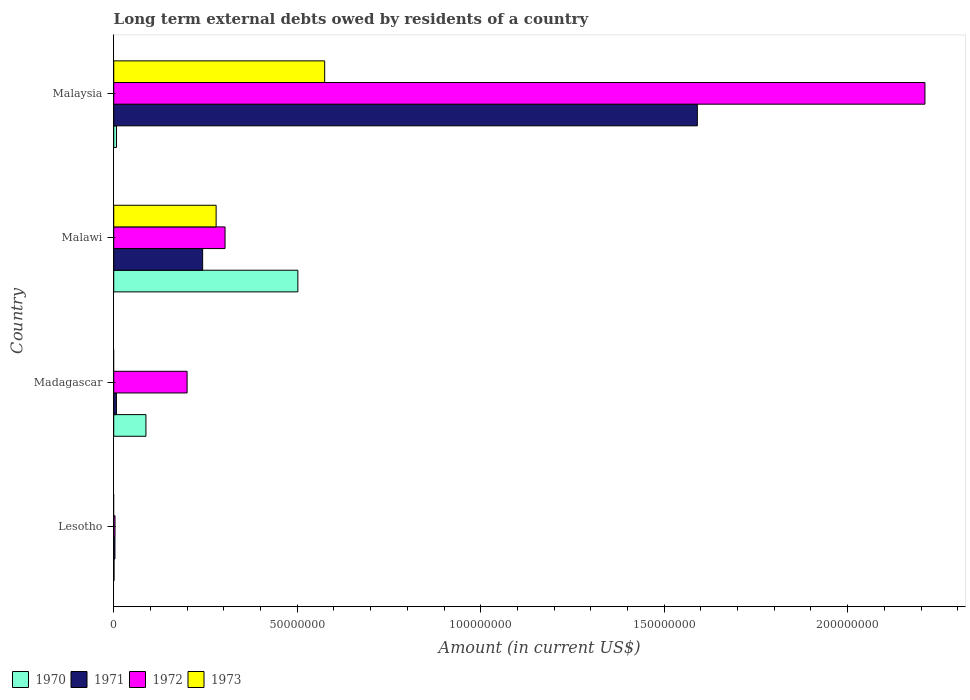How many groups of bars are there?
Offer a terse response. 4. Are the number of bars on each tick of the Y-axis equal?
Provide a succinct answer. No. What is the label of the 2nd group of bars from the top?
Your response must be concise. Malawi. What is the amount of long-term external debts owed by residents in 1970 in Lesotho?
Make the answer very short. 7.60e+04. Across all countries, what is the maximum amount of long-term external debts owed by residents in 1973?
Your response must be concise. 5.75e+07. Across all countries, what is the minimum amount of long-term external debts owed by residents in 1970?
Give a very brief answer. 7.60e+04. In which country was the amount of long-term external debts owed by residents in 1972 maximum?
Your answer should be compact. Malaysia. What is the total amount of long-term external debts owed by residents in 1972 in the graph?
Provide a succinct answer. 2.72e+08. What is the difference between the amount of long-term external debts owed by residents in 1971 in Madagascar and that in Malaysia?
Provide a succinct answer. -1.58e+08. What is the difference between the amount of long-term external debts owed by residents in 1971 in Malaysia and the amount of long-term external debts owed by residents in 1970 in Lesotho?
Make the answer very short. 1.59e+08. What is the average amount of long-term external debts owed by residents in 1972 per country?
Make the answer very short. 6.79e+07. What is the difference between the amount of long-term external debts owed by residents in 1970 and amount of long-term external debts owed by residents in 1971 in Lesotho?
Provide a succinct answer. -2.50e+05. In how many countries, is the amount of long-term external debts owed by residents in 1972 greater than 60000000 US$?
Offer a very short reply. 1. What is the ratio of the amount of long-term external debts owed by residents in 1973 in Malawi to that in Malaysia?
Your answer should be compact. 0.49. What is the difference between the highest and the second highest amount of long-term external debts owed by residents in 1970?
Your answer should be very brief. 4.14e+07. What is the difference between the highest and the lowest amount of long-term external debts owed by residents in 1970?
Offer a terse response. 5.01e+07. Is it the case that in every country, the sum of the amount of long-term external debts owed by residents in 1971 and amount of long-term external debts owed by residents in 1972 is greater than the sum of amount of long-term external debts owed by residents in 1970 and amount of long-term external debts owed by residents in 1973?
Offer a very short reply. No. How many bars are there?
Ensure brevity in your answer.  14. Are all the bars in the graph horizontal?
Offer a very short reply. Yes. What is the difference between two consecutive major ticks on the X-axis?
Keep it short and to the point. 5.00e+07. Are the values on the major ticks of X-axis written in scientific E-notation?
Your answer should be compact. No. Does the graph contain grids?
Provide a short and direct response. No. What is the title of the graph?
Give a very brief answer. Long term external debts owed by residents of a country. What is the Amount (in current US$) of 1970 in Lesotho?
Provide a succinct answer. 7.60e+04. What is the Amount (in current US$) of 1971 in Lesotho?
Your answer should be compact. 3.26e+05. What is the Amount (in current US$) of 1972 in Lesotho?
Keep it short and to the point. 3.48e+05. What is the Amount (in current US$) of 1973 in Lesotho?
Offer a terse response. 0. What is the Amount (in current US$) of 1970 in Madagascar?
Give a very brief answer. 8.78e+06. What is the Amount (in current US$) of 1971 in Madagascar?
Ensure brevity in your answer.  7.30e+05. What is the Amount (in current US$) in 1972 in Madagascar?
Provide a succinct answer. 2.00e+07. What is the Amount (in current US$) of 1970 in Malawi?
Ensure brevity in your answer.  5.02e+07. What is the Amount (in current US$) of 1971 in Malawi?
Your answer should be very brief. 2.42e+07. What is the Amount (in current US$) in 1972 in Malawi?
Your answer should be compact. 3.03e+07. What is the Amount (in current US$) of 1973 in Malawi?
Your answer should be compact. 2.79e+07. What is the Amount (in current US$) of 1970 in Malaysia?
Keep it short and to the point. 7.56e+05. What is the Amount (in current US$) in 1971 in Malaysia?
Give a very brief answer. 1.59e+08. What is the Amount (in current US$) in 1972 in Malaysia?
Offer a very short reply. 2.21e+08. What is the Amount (in current US$) of 1973 in Malaysia?
Give a very brief answer. 5.75e+07. Across all countries, what is the maximum Amount (in current US$) in 1970?
Offer a terse response. 5.02e+07. Across all countries, what is the maximum Amount (in current US$) of 1971?
Provide a succinct answer. 1.59e+08. Across all countries, what is the maximum Amount (in current US$) of 1972?
Offer a very short reply. 2.21e+08. Across all countries, what is the maximum Amount (in current US$) in 1973?
Provide a succinct answer. 5.75e+07. Across all countries, what is the minimum Amount (in current US$) in 1970?
Ensure brevity in your answer.  7.60e+04. Across all countries, what is the minimum Amount (in current US$) of 1971?
Your answer should be compact. 3.26e+05. Across all countries, what is the minimum Amount (in current US$) of 1972?
Offer a terse response. 3.48e+05. Across all countries, what is the minimum Amount (in current US$) in 1973?
Keep it short and to the point. 0. What is the total Amount (in current US$) in 1970 in the graph?
Ensure brevity in your answer.  5.98e+07. What is the total Amount (in current US$) of 1971 in the graph?
Ensure brevity in your answer.  1.84e+08. What is the total Amount (in current US$) in 1972 in the graph?
Provide a short and direct response. 2.72e+08. What is the total Amount (in current US$) in 1973 in the graph?
Offer a terse response. 8.54e+07. What is the difference between the Amount (in current US$) in 1970 in Lesotho and that in Madagascar?
Your response must be concise. -8.70e+06. What is the difference between the Amount (in current US$) of 1971 in Lesotho and that in Madagascar?
Offer a terse response. -4.04e+05. What is the difference between the Amount (in current US$) in 1972 in Lesotho and that in Madagascar?
Keep it short and to the point. -1.96e+07. What is the difference between the Amount (in current US$) of 1970 in Lesotho and that in Malawi?
Your answer should be very brief. -5.01e+07. What is the difference between the Amount (in current US$) in 1971 in Lesotho and that in Malawi?
Your answer should be very brief. -2.39e+07. What is the difference between the Amount (in current US$) in 1972 in Lesotho and that in Malawi?
Offer a terse response. -3.00e+07. What is the difference between the Amount (in current US$) in 1970 in Lesotho and that in Malaysia?
Your response must be concise. -6.80e+05. What is the difference between the Amount (in current US$) in 1971 in Lesotho and that in Malaysia?
Keep it short and to the point. -1.59e+08. What is the difference between the Amount (in current US$) in 1972 in Lesotho and that in Malaysia?
Offer a very short reply. -2.21e+08. What is the difference between the Amount (in current US$) of 1970 in Madagascar and that in Malawi?
Provide a succinct answer. -4.14e+07. What is the difference between the Amount (in current US$) in 1971 in Madagascar and that in Malawi?
Keep it short and to the point. -2.35e+07. What is the difference between the Amount (in current US$) of 1972 in Madagascar and that in Malawi?
Your response must be concise. -1.03e+07. What is the difference between the Amount (in current US$) of 1970 in Madagascar and that in Malaysia?
Ensure brevity in your answer.  8.02e+06. What is the difference between the Amount (in current US$) of 1971 in Madagascar and that in Malaysia?
Provide a short and direct response. -1.58e+08. What is the difference between the Amount (in current US$) in 1972 in Madagascar and that in Malaysia?
Give a very brief answer. -2.01e+08. What is the difference between the Amount (in current US$) in 1970 in Malawi and that in Malaysia?
Make the answer very short. 4.94e+07. What is the difference between the Amount (in current US$) in 1971 in Malawi and that in Malaysia?
Make the answer very short. -1.35e+08. What is the difference between the Amount (in current US$) of 1972 in Malawi and that in Malaysia?
Provide a succinct answer. -1.91e+08. What is the difference between the Amount (in current US$) of 1973 in Malawi and that in Malaysia?
Offer a very short reply. -2.96e+07. What is the difference between the Amount (in current US$) in 1970 in Lesotho and the Amount (in current US$) in 1971 in Madagascar?
Provide a succinct answer. -6.54e+05. What is the difference between the Amount (in current US$) in 1970 in Lesotho and the Amount (in current US$) in 1972 in Madagascar?
Your answer should be compact. -1.99e+07. What is the difference between the Amount (in current US$) in 1971 in Lesotho and the Amount (in current US$) in 1972 in Madagascar?
Offer a terse response. -1.97e+07. What is the difference between the Amount (in current US$) in 1970 in Lesotho and the Amount (in current US$) in 1971 in Malawi?
Your answer should be compact. -2.42e+07. What is the difference between the Amount (in current US$) of 1970 in Lesotho and the Amount (in current US$) of 1972 in Malawi?
Offer a very short reply. -3.03e+07. What is the difference between the Amount (in current US$) in 1970 in Lesotho and the Amount (in current US$) in 1973 in Malawi?
Offer a terse response. -2.78e+07. What is the difference between the Amount (in current US$) of 1971 in Lesotho and the Amount (in current US$) of 1972 in Malawi?
Offer a terse response. -3.00e+07. What is the difference between the Amount (in current US$) in 1971 in Lesotho and the Amount (in current US$) in 1973 in Malawi?
Offer a very short reply. -2.76e+07. What is the difference between the Amount (in current US$) of 1972 in Lesotho and the Amount (in current US$) of 1973 in Malawi?
Provide a short and direct response. -2.76e+07. What is the difference between the Amount (in current US$) in 1970 in Lesotho and the Amount (in current US$) in 1971 in Malaysia?
Make the answer very short. -1.59e+08. What is the difference between the Amount (in current US$) of 1970 in Lesotho and the Amount (in current US$) of 1972 in Malaysia?
Make the answer very short. -2.21e+08. What is the difference between the Amount (in current US$) of 1970 in Lesotho and the Amount (in current US$) of 1973 in Malaysia?
Make the answer very short. -5.74e+07. What is the difference between the Amount (in current US$) of 1971 in Lesotho and the Amount (in current US$) of 1972 in Malaysia?
Provide a succinct answer. -2.21e+08. What is the difference between the Amount (in current US$) in 1971 in Lesotho and the Amount (in current US$) in 1973 in Malaysia?
Offer a terse response. -5.72e+07. What is the difference between the Amount (in current US$) of 1972 in Lesotho and the Amount (in current US$) of 1973 in Malaysia?
Make the answer very short. -5.71e+07. What is the difference between the Amount (in current US$) in 1970 in Madagascar and the Amount (in current US$) in 1971 in Malawi?
Offer a terse response. -1.55e+07. What is the difference between the Amount (in current US$) of 1970 in Madagascar and the Amount (in current US$) of 1972 in Malawi?
Your response must be concise. -2.16e+07. What is the difference between the Amount (in current US$) of 1970 in Madagascar and the Amount (in current US$) of 1973 in Malawi?
Offer a very short reply. -1.91e+07. What is the difference between the Amount (in current US$) of 1971 in Madagascar and the Amount (in current US$) of 1972 in Malawi?
Provide a short and direct response. -2.96e+07. What is the difference between the Amount (in current US$) in 1971 in Madagascar and the Amount (in current US$) in 1973 in Malawi?
Give a very brief answer. -2.72e+07. What is the difference between the Amount (in current US$) in 1972 in Madagascar and the Amount (in current US$) in 1973 in Malawi?
Your answer should be very brief. -7.91e+06. What is the difference between the Amount (in current US$) in 1970 in Madagascar and the Amount (in current US$) in 1971 in Malaysia?
Offer a very short reply. -1.50e+08. What is the difference between the Amount (in current US$) in 1970 in Madagascar and the Amount (in current US$) in 1972 in Malaysia?
Ensure brevity in your answer.  -2.12e+08. What is the difference between the Amount (in current US$) in 1970 in Madagascar and the Amount (in current US$) in 1973 in Malaysia?
Offer a very short reply. -4.87e+07. What is the difference between the Amount (in current US$) in 1971 in Madagascar and the Amount (in current US$) in 1972 in Malaysia?
Give a very brief answer. -2.20e+08. What is the difference between the Amount (in current US$) of 1971 in Madagascar and the Amount (in current US$) of 1973 in Malaysia?
Your response must be concise. -5.68e+07. What is the difference between the Amount (in current US$) in 1972 in Madagascar and the Amount (in current US$) in 1973 in Malaysia?
Provide a succinct answer. -3.75e+07. What is the difference between the Amount (in current US$) in 1970 in Malawi and the Amount (in current US$) in 1971 in Malaysia?
Your answer should be compact. -1.09e+08. What is the difference between the Amount (in current US$) in 1970 in Malawi and the Amount (in current US$) in 1972 in Malaysia?
Your answer should be compact. -1.71e+08. What is the difference between the Amount (in current US$) of 1970 in Malawi and the Amount (in current US$) of 1973 in Malaysia?
Keep it short and to the point. -7.31e+06. What is the difference between the Amount (in current US$) of 1971 in Malawi and the Amount (in current US$) of 1972 in Malaysia?
Offer a terse response. -1.97e+08. What is the difference between the Amount (in current US$) in 1971 in Malawi and the Amount (in current US$) in 1973 in Malaysia?
Make the answer very short. -3.33e+07. What is the difference between the Amount (in current US$) in 1972 in Malawi and the Amount (in current US$) in 1973 in Malaysia?
Offer a terse response. -2.72e+07. What is the average Amount (in current US$) of 1970 per country?
Your answer should be very brief. 1.49e+07. What is the average Amount (in current US$) in 1971 per country?
Provide a short and direct response. 4.61e+07. What is the average Amount (in current US$) of 1972 per country?
Offer a terse response. 6.79e+07. What is the average Amount (in current US$) in 1973 per country?
Give a very brief answer. 2.13e+07. What is the difference between the Amount (in current US$) of 1970 and Amount (in current US$) of 1971 in Lesotho?
Offer a very short reply. -2.50e+05. What is the difference between the Amount (in current US$) of 1970 and Amount (in current US$) of 1972 in Lesotho?
Keep it short and to the point. -2.72e+05. What is the difference between the Amount (in current US$) of 1971 and Amount (in current US$) of 1972 in Lesotho?
Make the answer very short. -2.20e+04. What is the difference between the Amount (in current US$) in 1970 and Amount (in current US$) in 1971 in Madagascar?
Your answer should be compact. 8.04e+06. What is the difference between the Amount (in current US$) of 1970 and Amount (in current US$) of 1972 in Madagascar?
Provide a short and direct response. -1.12e+07. What is the difference between the Amount (in current US$) in 1971 and Amount (in current US$) in 1972 in Madagascar?
Give a very brief answer. -1.93e+07. What is the difference between the Amount (in current US$) in 1970 and Amount (in current US$) in 1971 in Malawi?
Your answer should be compact. 2.59e+07. What is the difference between the Amount (in current US$) in 1970 and Amount (in current US$) in 1972 in Malawi?
Keep it short and to the point. 1.98e+07. What is the difference between the Amount (in current US$) of 1970 and Amount (in current US$) of 1973 in Malawi?
Your answer should be compact. 2.23e+07. What is the difference between the Amount (in current US$) in 1971 and Amount (in current US$) in 1972 in Malawi?
Provide a short and direct response. -6.11e+06. What is the difference between the Amount (in current US$) in 1971 and Amount (in current US$) in 1973 in Malawi?
Make the answer very short. -3.67e+06. What is the difference between the Amount (in current US$) in 1972 and Amount (in current US$) in 1973 in Malawi?
Give a very brief answer. 2.43e+06. What is the difference between the Amount (in current US$) in 1970 and Amount (in current US$) in 1971 in Malaysia?
Keep it short and to the point. -1.58e+08. What is the difference between the Amount (in current US$) of 1970 and Amount (in current US$) of 1972 in Malaysia?
Your answer should be very brief. -2.20e+08. What is the difference between the Amount (in current US$) of 1970 and Amount (in current US$) of 1973 in Malaysia?
Your response must be concise. -5.67e+07. What is the difference between the Amount (in current US$) in 1971 and Amount (in current US$) in 1972 in Malaysia?
Provide a succinct answer. -6.20e+07. What is the difference between the Amount (in current US$) of 1971 and Amount (in current US$) of 1973 in Malaysia?
Give a very brief answer. 1.02e+08. What is the difference between the Amount (in current US$) in 1972 and Amount (in current US$) in 1973 in Malaysia?
Offer a terse response. 1.64e+08. What is the ratio of the Amount (in current US$) in 1970 in Lesotho to that in Madagascar?
Ensure brevity in your answer.  0.01. What is the ratio of the Amount (in current US$) of 1971 in Lesotho to that in Madagascar?
Ensure brevity in your answer.  0.45. What is the ratio of the Amount (in current US$) of 1972 in Lesotho to that in Madagascar?
Provide a short and direct response. 0.02. What is the ratio of the Amount (in current US$) of 1970 in Lesotho to that in Malawi?
Provide a short and direct response. 0. What is the ratio of the Amount (in current US$) in 1971 in Lesotho to that in Malawi?
Offer a very short reply. 0.01. What is the ratio of the Amount (in current US$) in 1972 in Lesotho to that in Malawi?
Your answer should be compact. 0.01. What is the ratio of the Amount (in current US$) of 1970 in Lesotho to that in Malaysia?
Offer a terse response. 0.1. What is the ratio of the Amount (in current US$) of 1971 in Lesotho to that in Malaysia?
Keep it short and to the point. 0. What is the ratio of the Amount (in current US$) of 1972 in Lesotho to that in Malaysia?
Make the answer very short. 0. What is the ratio of the Amount (in current US$) of 1970 in Madagascar to that in Malawi?
Your answer should be very brief. 0.17. What is the ratio of the Amount (in current US$) of 1971 in Madagascar to that in Malawi?
Give a very brief answer. 0.03. What is the ratio of the Amount (in current US$) of 1972 in Madagascar to that in Malawi?
Make the answer very short. 0.66. What is the ratio of the Amount (in current US$) of 1970 in Madagascar to that in Malaysia?
Your answer should be compact. 11.61. What is the ratio of the Amount (in current US$) in 1971 in Madagascar to that in Malaysia?
Ensure brevity in your answer.  0. What is the ratio of the Amount (in current US$) in 1972 in Madagascar to that in Malaysia?
Provide a succinct answer. 0.09. What is the ratio of the Amount (in current US$) of 1970 in Malawi to that in Malaysia?
Your answer should be compact. 66.37. What is the ratio of the Amount (in current US$) in 1971 in Malawi to that in Malaysia?
Provide a succinct answer. 0.15. What is the ratio of the Amount (in current US$) in 1972 in Malawi to that in Malaysia?
Provide a short and direct response. 0.14. What is the ratio of the Amount (in current US$) in 1973 in Malawi to that in Malaysia?
Provide a short and direct response. 0.49. What is the difference between the highest and the second highest Amount (in current US$) in 1970?
Provide a short and direct response. 4.14e+07. What is the difference between the highest and the second highest Amount (in current US$) of 1971?
Offer a terse response. 1.35e+08. What is the difference between the highest and the second highest Amount (in current US$) of 1972?
Ensure brevity in your answer.  1.91e+08. What is the difference between the highest and the lowest Amount (in current US$) of 1970?
Make the answer very short. 5.01e+07. What is the difference between the highest and the lowest Amount (in current US$) in 1971?
Your response must be concise. 1.59e+08. What is the difference between the highest and the lowest Amount (in current US$) of 1972?
Your answer should be very brief. 2.21e+08. What is the difference between the highest and the lowest Amount (in current US$) of 1973?
Ensure brevity in your answer.  5.75e+07. 